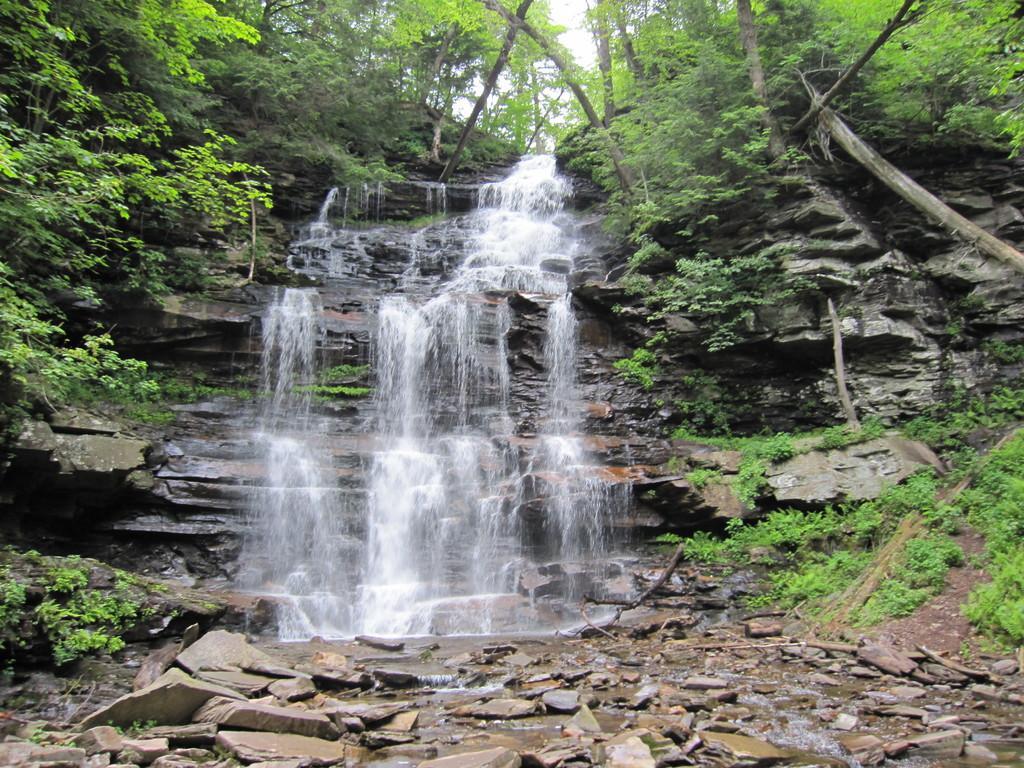In one or two sentences, can you explain what this image depicts? In the image there is a beautiful waterfall, around the waterfall there are many plants and trees. Under the waterfall there are broken stones. 